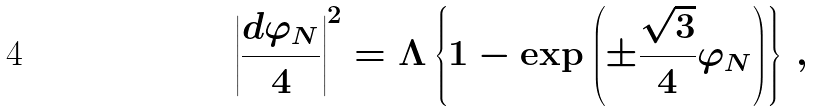<formula> <loc_0><loc_0><loc_500><loc_500>\left | \frac { d \varphi _ { N } } { 4 } \right | ^ { 2 } & = \Lambda \left \{ 1 - \exp \left ( \pm \frac { \sqrt { 3 } } { 4 } \varphi _ { N } \right ) \right \} \, ,</formula> 